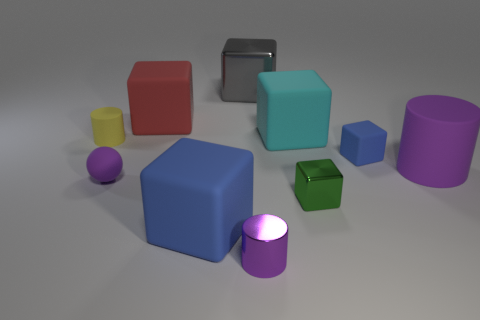There is a big cylinder that is the same color as the small matte sphere; what is its material?
Make the answer very short. Rubber. What material is the blue thing that is the same size as the gray shiny thing?
Your response must be concise. Rubber. Are there fewer cyan rubber objects that are in front of the small rubber cylinder than tiny metallic things that are to the right of the red rubber block?
Offer a very short reply. Yes. What shape is the thing that is right of the large gray object and behind the tiny blue block?
Give a very brief answer. Cube. How many large red rubber things have the same shape as the small blue thing?
Your response must be concise. 1. What is the size of the yellow object that is the same material as the cyan cube?
Your answer should be very brief. Small. Is the number of large yellow rubber objects greater than the number of large objects?
Your answer should be compact. No. There is a large matte object that is right of the big cyan block; what color is it?
Your answer should be very brief. Purple. What is the size of the rubber cube that is to the left of the big cyan thing and behind the tiny blue thing?
Keep it short and to the point. Large. What number of gray metallic blocks are the same size as the red matte object?
Ensure brevity in your answer.  1. 